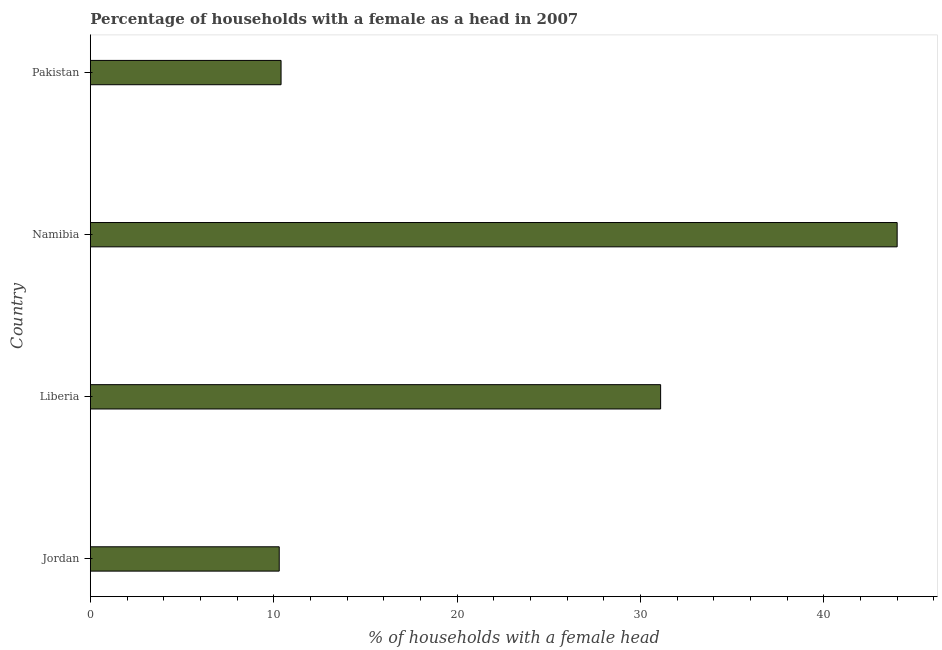Does the graph contain grids?
Keep it short and to the point. No. What is the title of the graph?
Give a very brief answer. Percentage of households with a female as a head in 2007. What is the label or title of the X-axis?
Provide a short and direct response. % of households with a female head. What is the number of female supervised households in Jordan?
Your answer should be compact. 10.3. In which country was the number of female supervised households maximum?
Keep it short and to the point. Namibia. In which country was the number of female supervised households minimum?
Ensure brevity in your answer.  Jordan. What is the sum of the number of female supervised households?
Provide a short and direct response. 95.8. What is the average number of female supervised households per country?
Provide a short and direct response. 23.95. What is the median number of female supervised households?
Keep it short and to the point. 20.75. What is the ratio of the number of female supervised households in Jordan to that in Pakistan?
Keep it short and to the point. 0.99. Is the number of female supervised households in Jordan less than that in Pakistan?
Give a very brief answer. Yes. What is the difference between the highest and the second highest number of female supervised households?
Ensure brevity in your answer.  12.9. What is the difference between the highest and the lowest number of female supervised households?
Ensure brevity in your answer.  33.7. How many bars are there?
Ensure brevity in your answer.  4. How many countries are there in the graph?
Keep it short and to the point. 4. Are the values on the major ticks of X-axis written in scientific E-notation?
Your response must be concise. No. What is the % of households with a female head in Liberia?
Offer a terse response. 31.1. What is the % of households with a female head of Namibia?
Provide a short and direct response. 44. What is the % of households with a female head in Pakistan?
Provide a succinct answer. 10.4. What is the difference between the % of households with a female head in Jordan and Liberia?
Provide a succinct answer. -20.8. What is the difference between the % of households with a female head in Jordan and Namibia?
Ensure brevity in your answer.  -33.7. What is the difference between the % of households with a female head in Jordan and Pakistan?
Your response must be concise. -0.1. What is the difference between the % of households with a female head in Liberia and Pakistan?
Your answer should be compact. 20.7. What is the difference between the % of households with a female head in Namibia and Pakistan?
Offer a terse response. 33.6. What is the ratio of the % of households with a female head in Jordan to that in Liberia?
Provide a succinct answer. 0.33. What is the ratio of the % of households with a female head in Jordan to that in Namibia?
Give a very brief answer. 0.23. What is the ratio of the % of households with a female head in Liberia to that in Namibia?
Your answer should be compact. 0.71. What is the ratio of the % of households with a female head in Liberia to that in Pakistan?
Your answer should be very brief. 2.99. What is the ratio of the % of households with a female head in Namibia to that in Pakistan?
Give a very brief answer. 4.23. 